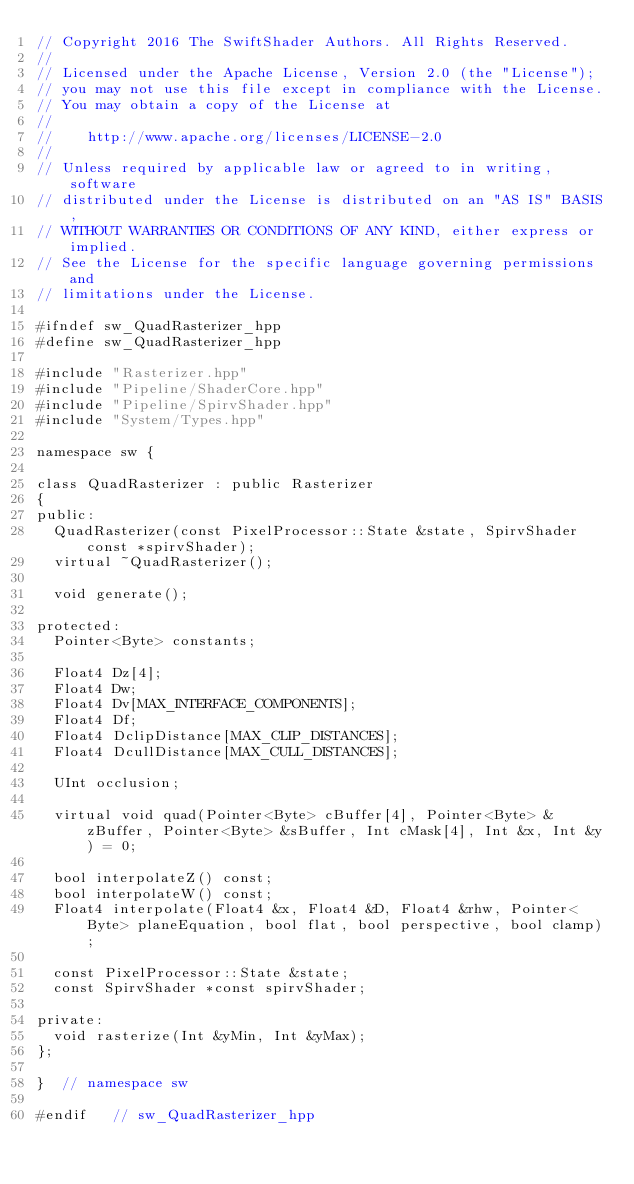<code> <loc_0><loc_0><loc_500><loc_500><_C++_>// Copyright 2016 The SwiftShader Authors. All Rights Reserved.
//
// Licensed under the Apache License, Version 2.0 (the "License");
// you may not use this file except in compliance with the License.
// You may obtain a copy of the License at
//
//    http://www.apache.org/licenses/LICENSE-2.0
//
// Unless required by applicable law or agreed to in writing, software
// distributed under the License is distributed on an "AS IS" BASIS,
// WITHOUT WARRANTIES OR CONDITIONS OF ANY KIND, either express or implied.
// See the License for the specific language governing permissions and
// limitations under the License.

#ifndef sw_QuadRasterizer_hpp
#define sw_QuadRasterizer_hpp

#include "Rasterizer.hpp"
#include "Pipeline/ShaderCore.hpp"
#include "Pipeline/SpirvShader.hpp"
#include "System/Types.hpp"

namespace sw {

class QuadRasterizer : public Rasterizer
{
public:
	QuadRasterizer(const PixelProcessor::State &state, SpirvShader const *spirvShader);
	virtual ~QuadRasterizer();

	void generate();

protected:
	Pointer<Byte> constants;

	Float4 Dz[4];
	Float4 Dw;
	Float4 Dv[MAX_INTERFACE_COMPONENTS];
	Float4 Df;
	Float4 DclipDistance[MAX_CLIP_DISTANCES];
	Float4 DcullDistance[MAX_CULL_DISTANCES];

	UInt occlusion;

	virtual void quad(Pointer<Byte> cBuffer[4], Pointer<Byte> &zBuffer, Pointer<Byte> &sBuffer, Int cMask[4], Int &x, Int &y) = 0;

	bool interpolateZ() const;
	bool interpolateW() const;
	Float4 interpolate(Float4 &x, Float4 &D, Float4 &rhw, Pointer<Byte> planeEquation, bool flat, bool perspective, bool clamp);

	const PixelProcessor::State &state;
	const SpirvShader *const spirvShader;

private:
	void rasterize(Int &yMin, Int &yMax);
};

}  // namespace sw

#endif   // sw_QuadRasterizer_hpp
</code> 